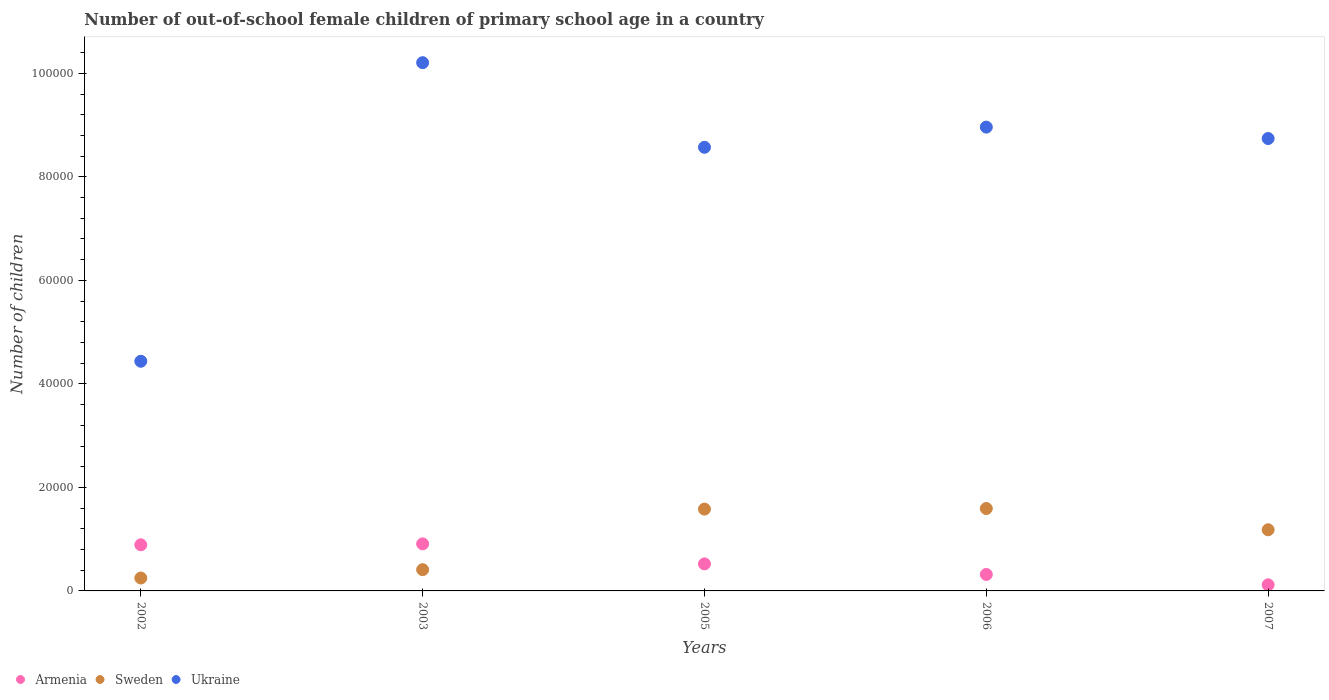Is the number of dotlines equal to the number of legend labels?
Keep it short and to the point. Yes. What is the number of out-of-school female children in Sweden in 2002?
Give a very brief answer. 2494. Across all years, what is the maximum number of out-of-school female children in Ukraine?
Provide a short and direct response. 1.02e+05. Across all years, what is the minimum number of out-of-school female children in Sweden?
Give a very brief answer. 2494. What is the total number of out-of-school female children in Armenia in the graph?
Your answer should be compact. 2.76e+04. What is the difference between the number of out-of-school female children in Armenia in 2002 and that in 2006?
Provide a short and direct response. 5728. What is the difference between the number of out-of-school female children in Sweden in 2002 and the number of out-of-school female children in Armenia in 2005?
Keep it short and to the point. -2729. What is the average number of out-of-school female children in Ukraine per year?
Give a very brief answer. 8.18e+04. In the year 2007, what is the difference between the number of out-of-school female children in Sweden and number of out-of-school female children in Ukraine?
Provide a short and direct response. -7.56e+04. In how many years, is the number of out-of-school female children in Sweden greater than 76000?
Give a very brief answer. 0. What is the ratio of the number of out-of-school female children in Ukraine in 2002 to that in 2005?
Offer a very short reply. 0.52. Is the number of out-of-school female children in Ukraine in 2003 less than that in 2006?
Keep it short and to the point. No. What is the difference between the highest and the second highest number of out-of-school female children in Armenia?
Make the answer very short. 181. What is the difference between the highest and the lowest number of out-of-school female children in Ukraine?
Your answer should be compact. 5.77e+04. Is it the case that in every year, the sum of the number of out-of-school female children in Sweden and number of out-of-school female children in Ukraine  is greater than the number of out-of-school female children in Armenia?
Make the answer very short. Yes. Is the number of out-of-school female children in Sweden strictly greater than the number of out-of-school female children in Ukraine over the years?
Your answer should be very brief. No. Is the number of out-of-school female children in Ukraine strictly less than the number of out-of-school female children in Sweden over the years?
Offer a terse response. No. Does the graph contain any zero values?
Your response must be concise. No. Does the graph contain grids?
Provide a succinct answer. No. Where does the legend appear in the graph?
Your answer should be compact. Bottom left. How many legend labels are there?
Offer a terse response. 3. How are the legend labels stacked?
Offer a very short reply. Horizontal. What is the title of the graph?
Keep it short and to the point. Number of out-of-school female children of primary school age in a country. What is the label or title of the X-axis?
Provide a succinct answer. Years. What is the label or title of the Y-axis?
Offer a terse response. Number of children. What is the Number of children of Armenia in 2002?
Keep it short and to the point. 8911. What is the Number of children in Sweden in 2002?
Your answer should be very brief. 2494. What is the Number of children in Ukraine in 2002?
Ensure brevity in your answer.  4.44e+04. What is the Number of children in Armenia in 2003?
Keep it short and to the point. 9092. What is the Number of children in Sweden in 2003?
Offer a terse response. 4107. What is the Number of children in Ukraine in 2003?
Keep it short and to the point. 1.02e+05. What is the Number of children in Armenia in 2005?
Your answer should be compact. 5223. What is the Number of children of Sweden in 2005?
Ensure brevity in your answer.  1.58e+04. What is the Number of children of Ukraine in 2005?
Offer a very short reply. 8.57e+04. What is the Number of children of Armenia in 2006?
Your answer should be very brief. 3183. What is the Number of children in Sweden in 2006?
Ensure brevity in your answer.  1.59e+04. What is the Number of children of Ukraine in 2006?
Offer a terse response. 8.96e+04. What is the Number of children of Armenia in 2007?
Keep it short and to the point. 1177. What is the Number of children of Sweden in 2007?
Your answer should be very brief. 1.18e+04. What is the Number of children in Ukraine in 2007?
Offer a terse response. 8.74e+04. Across all years, what is the maximum Number of children in Armenia?
Your answer should be very brief. 9092. Across all years, what is the maximum Number of children in Sweden?
Your response must be concise. 1.59e+04. Across all years, what is the maximum Number of children of Ukraine?
Give a very brief answer. 1.02e+05. Across all years, what is the minimum Number of children in Armenia?
Offer a terse response. 1177. Across all years, what is the minimum Number of children of Sweden?
Your answer should be compact. 2494. Across all years, what is the minimum Number of children in Ukraine?
Provide a short and direct response. 4.44e+04. What is the total Number of children in Armenia in the graph?
Offer a terse response. 2.76e+04. What is the total Number of children of Sweden in the graph?
Give a very brief answer. 5.01e+04. What is the total Number of children in Ukraine in the graph?
Provide a succinct answer. 4.09e+05. What is the difference between the Number of children in Armenia in 2002 and that in 2003?
Your response must be concise. -181. What is the difference between the Number of children of Sweden in 2002 and that in 2003?
Your answer should be compact. -1613. What is the difference between the Number of children in Ukraine in 2002 and that in 2003?
Keep it short and to the point. -5.77e+04. What is the difference between the Number of children in Armenia in 2002 and that in 2005?
Provide a succinct answer. 3688. What is the difference between the Number of children of Sweden in 2002 and that in 2005?
Your answer should be very brief. -1.33e+04. What is the difference between the Number of children in Ukraine in 2002 and that in 2005?
Offer a terse response. -4.13e+04. What is the difference between the Number of children in Armenia in 2002 and that in 2006?
Ensure brevity in your answer.  5728. What is the difference between the Number of children in Sweden in 2002 and that in 2006?
Your answer should be compact. -1.34e+04. What is the difference between the Number of children of Ukraine in 2002 and that in 2006?
Make the answer very short. -4.52e+04. What is the difference between the Number of children in Armenia in 2002 and that in 2007?
Provide a succinct answer. 7734. What is the difference between the Number of children of Sweden in 2002 and that in 2007?
Provide a succinct answer. -9321. What is the difference between the Number of children in Ukraine in 2002 and that in 2007?
Your answer should be compact. -4.30e+04. What is the difference between the Number of children in Armenia in 2003 and that in 2005?
Your answer should be compact. 3869. What is the difference between the Number of children of Sweden in 2003 and that in 2005?
Your answer should be very brief. -1.17e+04. What is the difference between the Number of children of Ukraine in 2003 and that in 2005?
Ensure brevity in your answer.  1.63e+04. What is the difference between the Number of children in Armenia in 2003 and that in 2006?
Offer a terse response. 5909. What is the difference between the Number of children of Sweden in 2003 and that in 2006?
Provide a short and direct response. -1.18e+04. What is the difference between the Number of children in Ukraine in 2003 and that in 2006?
Your answer should be very brief. 1.24e+04. What is the difference between the Number of children of Armenia in 2003 and that in 2007?
Provide a succinct answer. 7915. What is the difference between the Number of children in Sweden in 2003 and that in 2007?
Offer a very short reply. -7708. What is the difference between the Number of children in Ukraine in 2003 and that in 2007?
Your response must be concise. 1.47e+04. What is the difference between the Number of children in Armenia in 2005 and that in 2006?
Provide a short and direct response. 2040. What is the difference between the Number of children in Sweden in 2005 and that in 2006?
Offer a very short reply. -113. What is the difference between the Number of children in Ukraine in 2005 and that in 2006?
Keep it short and to the point. -3898. What is the difference between the Number of children in Armenia in 2005 and that in 2007?
Give a very brief answer. 4046. What is the difference between the Number of children in Sweden in 2005 and that in 2007?
Offer a very short reply. 3992. What is the difference between the Number of children in Ukraine in 2005 and that in 2007?
Ensure brevity in your answer.  -1694. What is the difference between the Number of children in Armenia in 2006 and that in 2007?
Give a very brief answer. 2006. What is the difference between the Number of children in Sweden in 2006 and that in 2007?
Offer a terse response. 4105. What is the difference between the Number of children in Ukraine in 2006 and that in 2007?
Provide a succinct answer. 2204. What is the difference between the Number of children of Armenia in 2002 and the Number of children of Sweden in 2003?
Your answer should be compact. 4804. What is the difference between the Number of children of Armenia in 2002 and the Number of children of Ukraine in 2003?
Offer a terse response. -9.32e+04. What is the difference between the Number of children of Sweden in 2002 and the Number of children of Ukraine in 2003?
Your response must be concise. -9.96e+04. What is the difference between the Number of children in Armenia in 2002 and the Number of children in Sweden in 2005?
Offer a very short reply. -6896. What is the difference between the Number of children in Armenia in 2002 and the Number of children in Ukraine in 2005?
Offer a terse response. -7.68e+04. What is the difference between the Number of children in Sweden in 2002 and the Number of children in Ukraine in 2005?
Offer a terse response. -8.32e+04. What is the difference between the Number of children in Armenia in 2002 and the Number of children in Sweden in 2006?
Make the answer very short. -7009. What is the difference between the Number of children of Armenia in 2002 and the Number of children of Ukraine in 2006?
Keep it short and to the point. -8.07e+04. What is the difference between the Number of children in Sweden in 2002 and the Number of children in Ukraine in 2006?
Make the answer very short. -8.71e+04. What is the difference between the Number of children in Armenia in 2002 and the Number of children in Sweden in 2007?
Keep it short and to the point. -2904. What is the difference between the Number of children in Armenia in 2002 and the Number of children in Ukraine in 2007?
Your answer should be very brief. -7.85e+04. What is the difference between the Number of children of Sweden in 2002 and the Number of children of Ukraine in 2007?
Give a very brief answer. -8.49e+04. What is the difference between the Number of children in Armenia in 2003 and the Number of children in Sweden in 2005?
Provide a short and direct response. -6715. What is the difference between the Number of children of Armenia in 2003 and the Number of children of Ukraine in 2005?
Ensure brevity in your answer.  -7.66e+04. What is the difference between the Number of children in Sweden in 2003 and the Number of children in Ukraine in 2005?
Provide a succinct answer. -8.16e+04. What is the difference between the Number of children in Armenia in 2003 and the Number of children in Sweden in 2006?
Provide a succinct answer. -6828. What is the difference between the Number of children of Armenia in 2003 and the Number of children of Ukraine in 2006?
Offer a very short reply. -8.05e+04. What is the difference between the Number of children in Sweden in 2003 and the Number of children in Ukraine in 2006?
Offer a terse response. -8.55e+04. What is the difference between the Number of children of Armenia in 2003 and the Number of children of Sweden in 2007?
Keep it short and to the point. -2723. What is the difference between the Number of children in Armenia in 2003 and the Number of children in Ukraine in 2007?
Keep it short and to the point. -7.83e+04. What is the difference between the Number of children in Sweden in 2003 and the Number of children in Ukraine in 2007?
Your answer should be very brief. -8.33e+04. What is the difference between the Number of children in Armenia in 2005 and the Number of children in Sweden in 2006?
Provide a succinct answer. -1.07e+04. What is the difference between the Number of children in Armenia in 2005 and the Number of children in Ukraine in 2006?
Keep it short and to the point. -8.44e+04. What is the difference between the Number of children in Sweden in 2005 and the Number of children in Ukraine in 2006?
Ensure brevity in your answer.  -7.38e+04. What is the difference between the Number of children of Armenia in 2005 and the Number of children of Sweden in 2007?
Provide a short and direct response. -6592. What is the difference between the Number of children of Armenia in 2005 and the Number of children of Ukraine in 2007?
Your answer should be compact. -8.22e+04. What is the difference between the Number of children in Sweden in 2005 and the Number of children in Ukraine in 2007?
Your answer should be very brief. -7.16e+04. What is the difference between the Number of children of Armenia in 2006 and the Number of children of Sweden in 2007?
Give a very brief answer. -8632. What is the difference between the Number of children of Armenia in 2006 and the Number of children of Ukraine in 2007?
Make the answer very short. -8.42e+04. What is the difference between the Number of children in Sweden in 2006 and the Number of children in Ukraine in 2007?
Offer a very short reply. -7.15e+04. What is the average Number of children in Armenia per year?
Keep it short and to the point. 5517.2. What is the average Number of children of Sweden per year?
Your response must be concise. 1.00e+04. What is the average Number of children in Ukraine per year?
Offer a terse response. 8.18e+04. In the year 2002, what is the difference between the Number of children in Armenia and Number of children in Sweden?
Your response must be concise. 6417. In the year 2002, what is the difference between the Number of children in Armenia and Number of children in Ukraine?
Offer a very short reply. -3.55e+04. In the year 2002, what is the difference between the Number of children of Sweden and Number of children of Ukraine?
Make the answer very short. -4.19e+04. In the year 2003, what is the difference between the Number of children in Armenia and Number of children in Sweden?
Give a very brief answer. 4985. In the year 2003, what is the difference between the Number of children of Armenia and Number of children of Ukraine?
Ensure brevity in your answer.  -9.30e+04. In the year 2003, what is the difference between the Number of children of Sweden and Number of children of Ukraine?
Make the answer very short. -9.80e+04. In the year 2005, what is the difference between the Number of children in Armenia and Number of children in Sweden?
Give a very brief answer. -1.06e+04. In the year 2005, what is the difference between the Number of children in Armenia and Number of children in Ukraine?
Keep it short and to the point. -8.05e+04. In the year 2005, what is the difference between the Number of children of Sweden and Number of children of Ukraine?
Offer a terse response. -6.99e+04. In the year 2006, what is the difference between the Number of children in Armenia and Number of children in Sweden?
Provide a succinct answer. -1.27e+04. In the year 2006, what is the difference between the Number of children in Armenia and Number of children in Ukraine?
Offer a terse response. -8.64e+04. In the year 2006, what is the difference between the Number of children in Sweden and Number of children in Ukraine?
Provide a short and direct response. -7.37e+04. In the year 2007, what is the difference between the Number of children in Armenia and Number of children in Sweden?
Ensure brevity in your answer.  -1.06e+04. In the year 2007, what is the difference between the Number of children of Armenia and Number of children of Ukraine?
Offer a terse response. -8.62e+04. In the year 2007, what is the difference between the Number of children of Sweden and Number of children of Ukraine?
Your answer should be very brief. -7.56e+04. What is the ratio of the Number of children in Armenia in 2002 to that in 2003?
Offer a very short reply. 0.98. What is the ratio of the Number of children of Sweden in 2002 to that in 2003?
Provide a succinct answer. 0.61. What is the ratio of the Number of children in Ukraine in 2002 to that in 2003?
Make the answer very short. 0.43. What is the ratio of the Number of children of Armenia in 2002 to that in 2005?
Your answer should be very brief. 1.71. What is the ratio of the Number of children in Sweden in 2002 to that in 2005?
Your answer should be compact. 0.16. What is the ratio of the Number of children of Ukraine in 2002 to that in 2005?
Keep it short and to the point. 0.52. What is the ratio of the Number of children in Armenia in 2002 to that in 2006?
Your answer should be very brief. 2.8. What is the ratio of the Number of children of Sweden in 2002 to that in 2006?
Your answer should be compact. 0.16. What is the ratio of the Number of children in Ukraine in 2002 to that in 2006?
Ensure brevity in your answer.  0.5. What is the ratio of the Number of children in Armenia in 2002 to that in 2007?
Give a very brief answer. 7.57. What is the ratio of the Number of children of Sweden in 2002 to that in 2007?
Your response must be concise. 0.21. What is the ratio of the Number of children in Ukraine in 2002 to that in 2007?
Offer a terse response. 0.51. What is the ratio of the Number of children of Armenia in 2003 to that in 2005?
Make the answer very short. 1.74. What is the ratio of the Number of children of Sweden in 2003 to that in 2005?
Provide a short and direct response. 0.26. What is the ratio of the Number of children in Ukraine in 2003 to that in 2005?
Give a very brief answer. 1.19. What is the ratio of the Number of children of Armenia in 2003 to that in 2006?
Your response must be concise. 2.86. What is the ratio of the Number of children of Sweden in 2003 to that in 2006?
Ensure brevity in your answer.  0.26. What is the ratio of the Number of children of Ukraine in 2003 to that in 2006?
Keep it short and to the point. 1.14. What is the ratio of the Number of children in Armenia in 2003 to that in 2007?
Keep it short and to the point. 7.72. What is the ratio of the Number of children in Sweden in 2003 to that in 2007?
Provide a short and direct response. 0.35. What is the ratio of the Number of children in Ukraine in 2003 to that in 2007?
Your answer should be compact. 1.17. What is the ratio of the Number of children of Armenia in 2005 to that in 2006?
Your answer should be compact. 1.64. What is the ratio of the Number of children of Ukraine in 2005 to that in 2006?
Your answer should be very brief. 0.96. What is the ratio of the Number of children of Armenia in 2005 to that in 2007?
Make the answer very short. 4.44. What is the ratio of the Number of children in Sweden in 2005 to that in 2007?
Offer a terse response. 1.34. What is the ratio of the Number of children in Ukraine in 2005 to that in 2007?
Your response must be concise. 0.98. What is the ratio of the Number of children of Armenia in 2006 to that in 2007?
Your answer should be compact. 2.7. What is the ratio of the Number of children in Sweden in 2006 to that in 2007?
Make the answer very short. 1.35. What is the ratio of the Number of children in Ukraine in 2006 to that in 2007?
Your answer should be compact. 1.03. What is the difference between the highest and the second highest Number of children in Armenia?
Ensure brevity in your answer.  181. What is the difference between the highest and the second highest Number of children in Sweden?
Make the answer very short. 113. What is the difference between the highest and the second highest Number of children in Ukraine?
Keep it short and to the point. 1.24e+04. What is the difference between the highest and the lowest Number of children in Armenia?
Provide a short and direct response. 7915. What is the difference between the highest and the lowest Number of children of Sweden?
Offer a very short reply. 1.34e+04. What is the difference between the highest and the lowest Number of children of Ukraine?
Make the answer very short. 5.77e+04. 